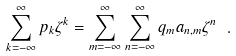Convert formula to latex. <formula><loc_0><loc_0><loc_500><loc_500>\sum _ { k = - \infty } ^ { \infty } p _ { k } \zeta ^ { k } = \sum _ { m = - \infty } ^ { \infty } \sum _ { n = - \infty } ^ { \infty } q _ { m } a _ { n , m } \zeta ^ { n } \ .</formula> 